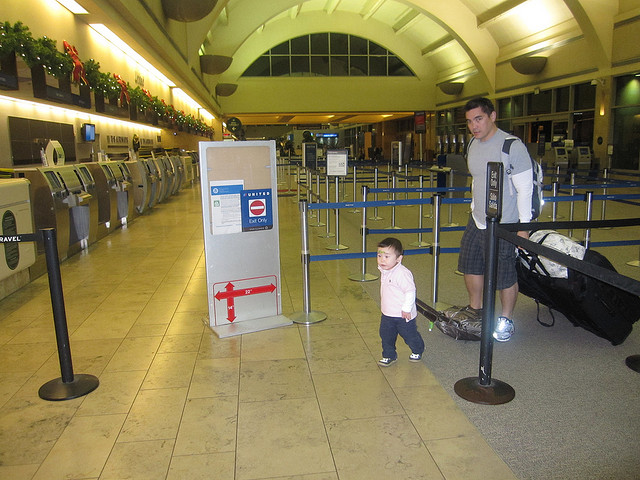Please extract the text content from this image. AVEL 